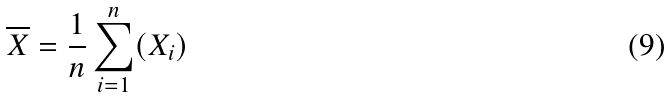<formula> <loc_0><loc_0><loc_500><loc_500>\overline { X } = \frac { 1 } { n } \sum _ { i = 1 } ^ { n } ( X _ { i } )</formula> 